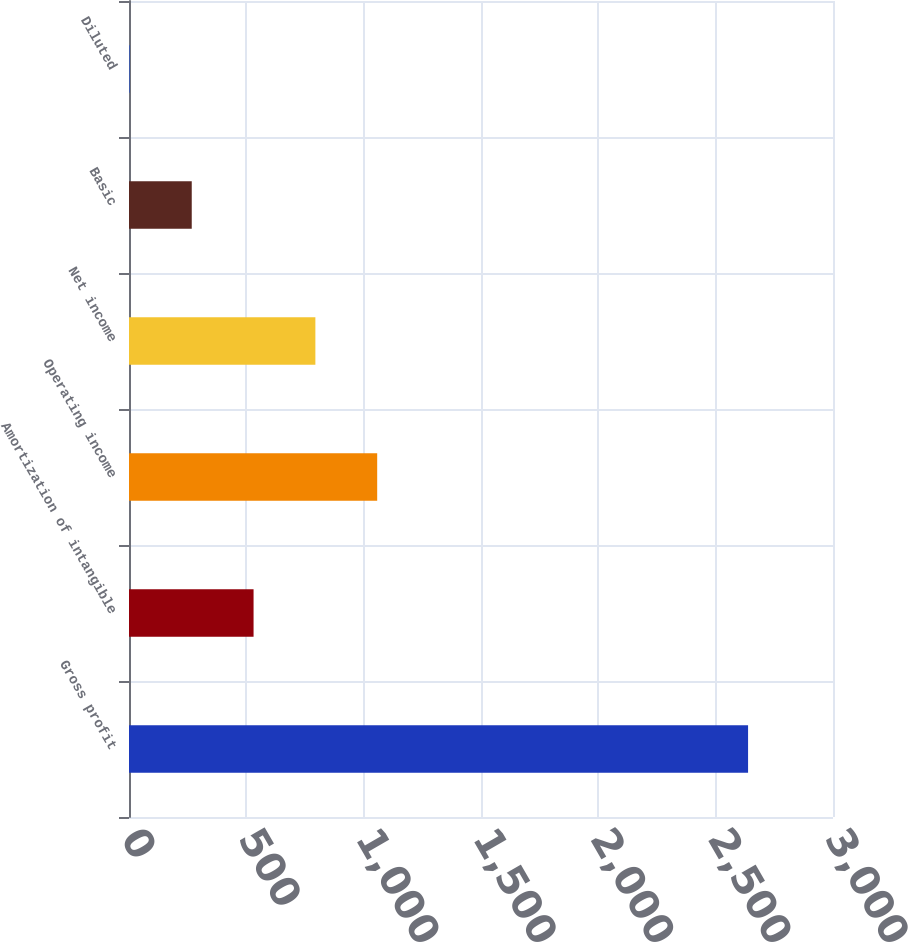Convert chart. <chart><loc_0><loc_0><loc_500><loc_500><bar_chart><fcel>Gross profit<fcel>Amortization of intangible<fcel>Operating income<fcel>Net income<fcel>Basic<fcel>Diluted<nl><fcel>2638.1<fcel>530.81<fcel>1057.63<fcel>794.22<fcel>267.4<fcel>3.99<nl></chart> 